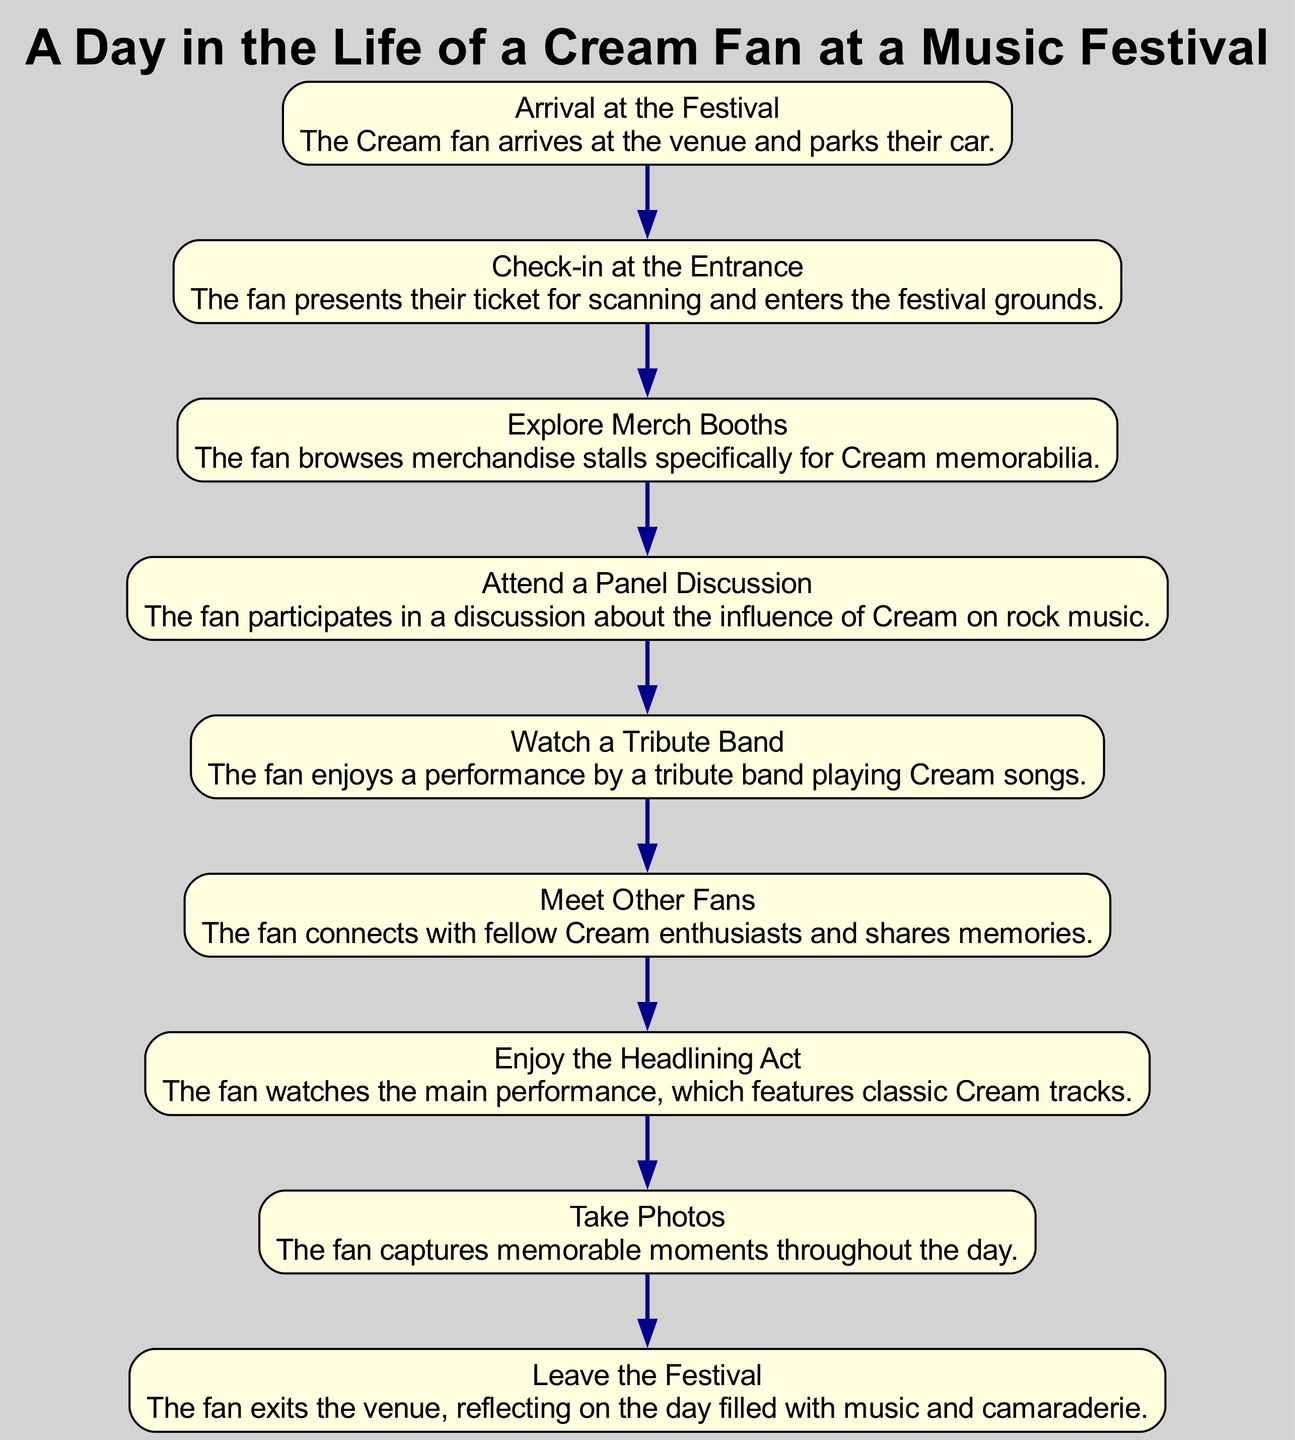What is the first event in the diagram? The first event is "Arrival at the Festival." It is the starting point of the sequence, and nothing precedes it in the diagram.
Answer: Arrival at the Festival How many events are depicted in the diagram? The diagram lists a total of 8 events, each representing a specific activity the fan engages in throughout the festival day. By counting the distinct events, we find the total number.
Answer: 8 What event follows "Check-in at the Entrance"? The event that follows "Check-in at the Entrance" is "Explore Merch Booths." Following the defined sequence, after checking in, the fan explores merchandise.
Answer: Explore Merch Booths Which event allows the fan to connect with others? The event where the fan connects with others is "Meet Other Fans." This event is specifically focused on fans interacting and sharing experiences.
Answer: Meet Other Fans What is the last event listed in the diagram? The last event listed in the diagram is "Leave the Festival." It concludes the day's activities as the fan reflects on their experiences after exiting the venue.
Answer: Leave the Festival How many nodes represent performance-related activities? There are 3 nodes representing performance-related activities: "Watch a Tribute Band," "Enjoy the Headlining Act," and "Take Photos." These events are focused on musical appreciation and capturing moments.
Answer: 3 What is the significance of the "Attend a Panel Discussion" event? The "Attend a Panel Discussion" event is significant as it engages the fan in a discussion about Cream's influence on rock music. This adds an educational aspect to the fan’s experience at the festival.
Answer: Educational aspect Which two events are directly linked to the experience of music? The two events directly linked to the experience of music are "Watch a Tribute Band" and "Enjoy the Headlining Act." These events focus on the enjoyment of live music performances.
Answer: Watch a Tribute Band, Enjoy the Headlining Act 